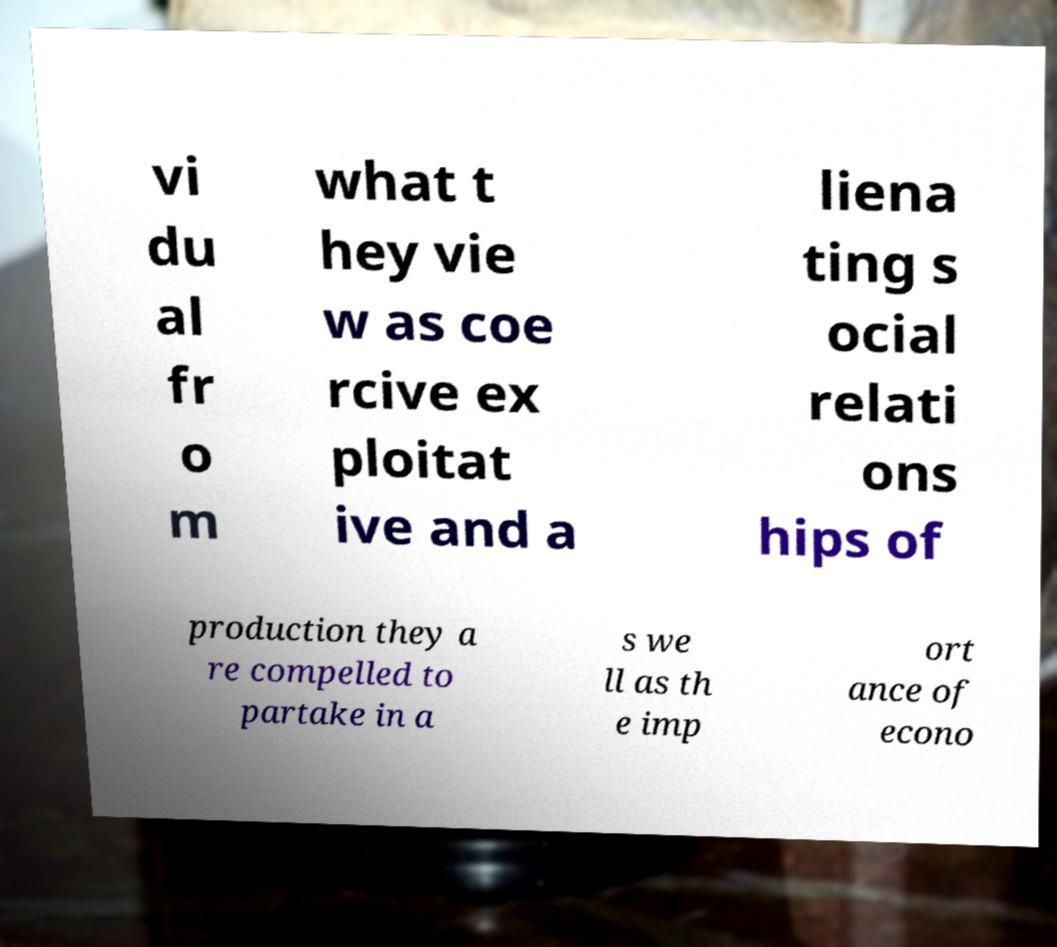Could you assist in decoding the text presented in this image and type it out clearly? vi du al fr o m what t hey vie w as coe rcive ex ploitat ive and a liena ting s ocial relati ons hips of production they a re compelled to partake in a s we ll as th e imp ort ance of econo 